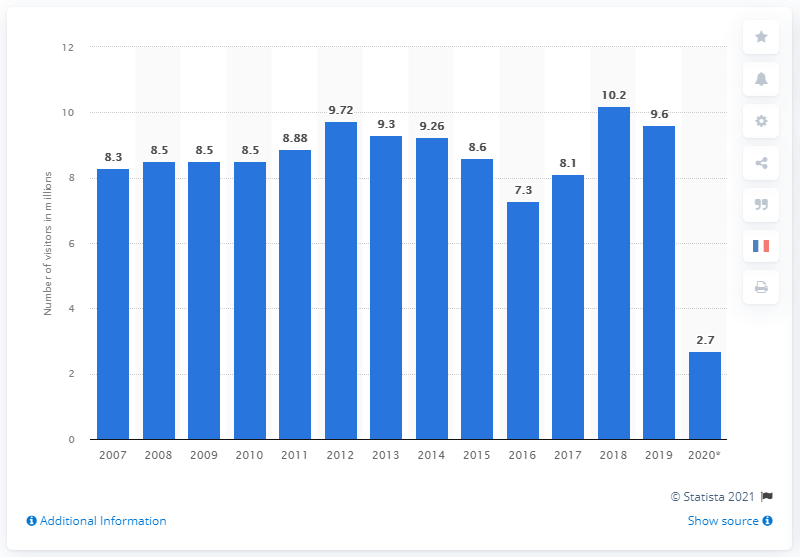Mention a couple of crucial points in this snapshot. In 2020, the Louvre was visited by approximately 2.7 million people. 